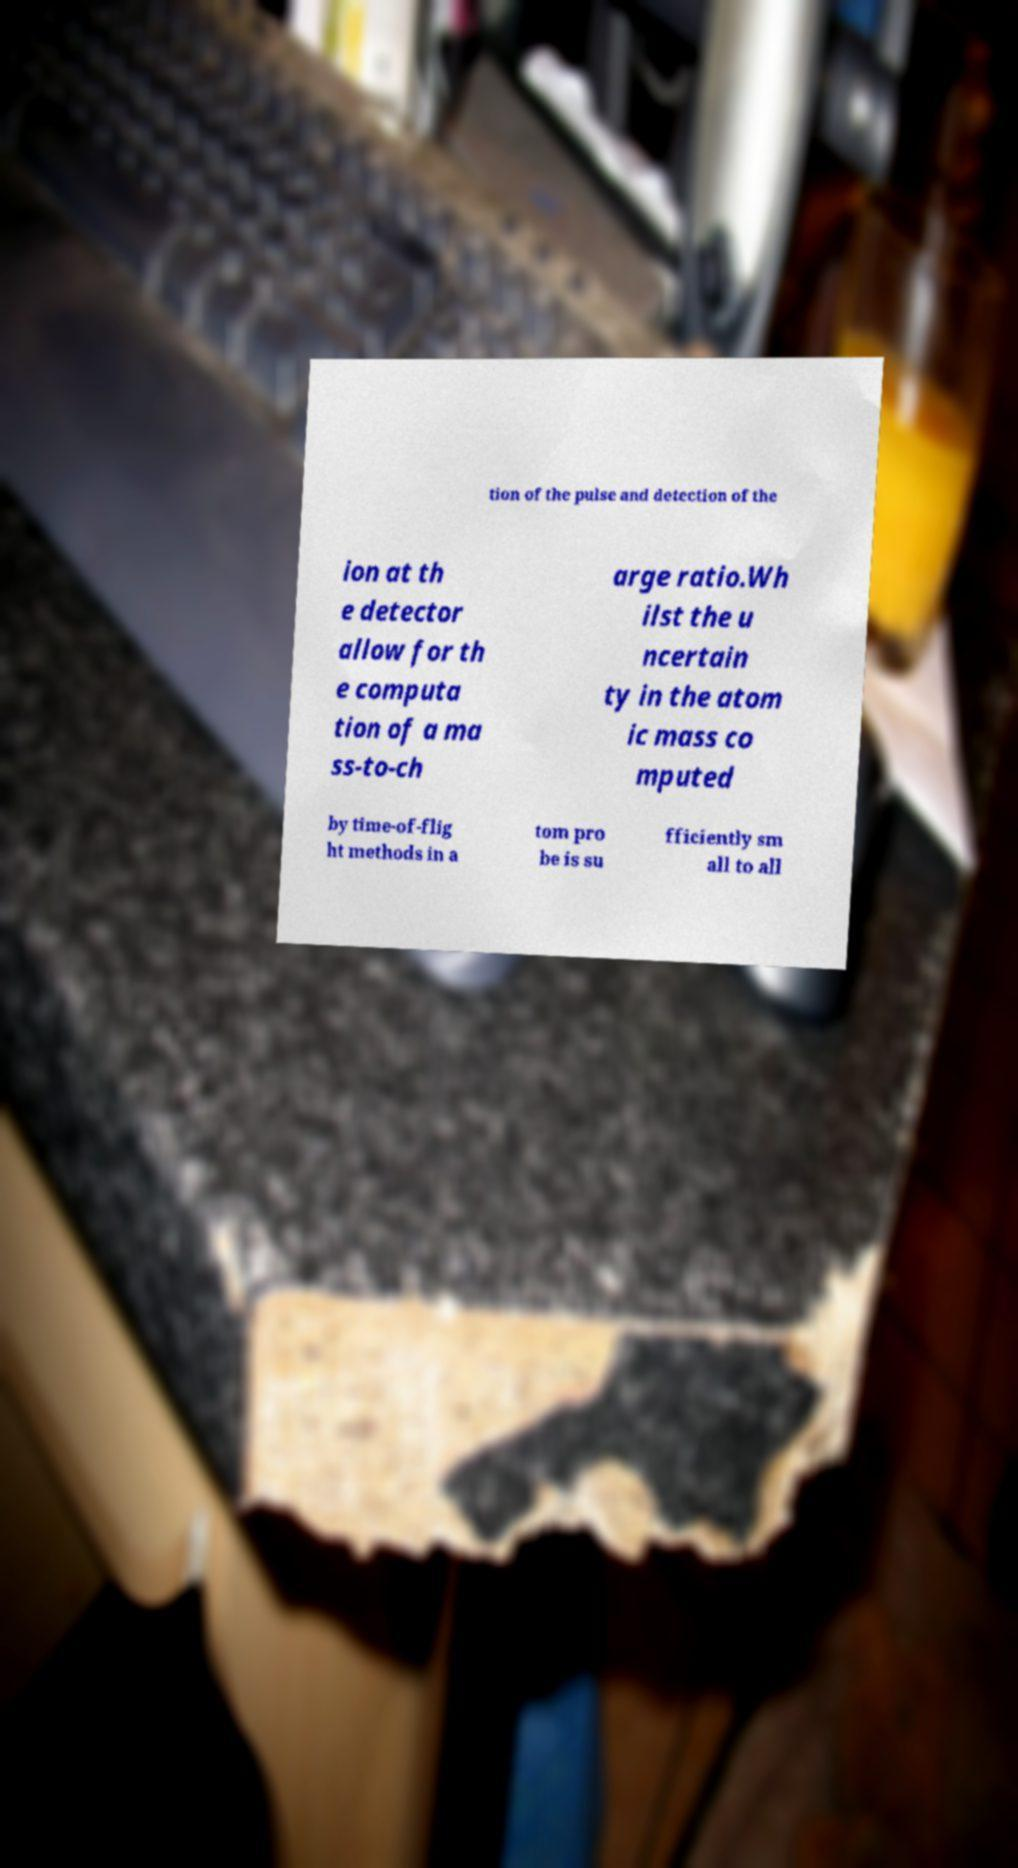I need the written content from this picture converted into text. Can you do that? tion of the pulse and detection of the ion at th e detector allow for th e computa tion of a ma ss-to-ch arge ratio.Wh ilst the u ncertain ty in the atom ic mass co mputed by time-of-flig ht methods in a tom pro be is su fficiently sm all to all 